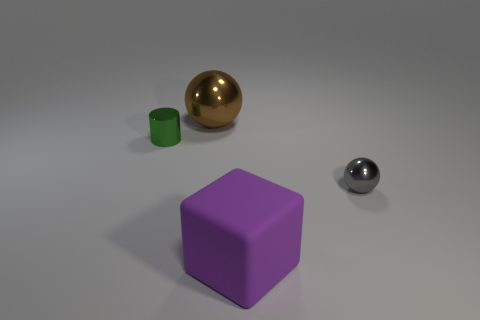What number of other objects are there of the same shape as the small gray thing?
Your answer should be compact. 1. What number of cubes are behind the large purple rubber block?
Offer a terse response. 0. Are there fewer small green metal cylinders that are behind the cylinder than blocks to the right of the gray metallic sphere?
Your response must be concise. No. What is the shape of the shiny thing that is to the right of the sphere that is to the left of the large object in front of the gray metal sphere?
Your answer should be very brief. Sphere. What is the shape of the thing that is on the left side of the small gray thing and in front of the small green object?
Offer a very short reply. Cube. Is there a tiny cyan object made of the same material as the small gray thing?
Offer a terse response. No. What is the color of the tiny thing behind the gray object?
Give a very brief answer. Green. There is a purple thing; does it have the same shape as the shiny object behind the cylinder?
Ensure brevity in your answer.  No. Are there any small metallic balls of the same color as the large ball?
Make the answer very short. No. There is a gray thing that is made of the same material as the tiny cylinder; what size is it?
Offer a very short reply. Small. 